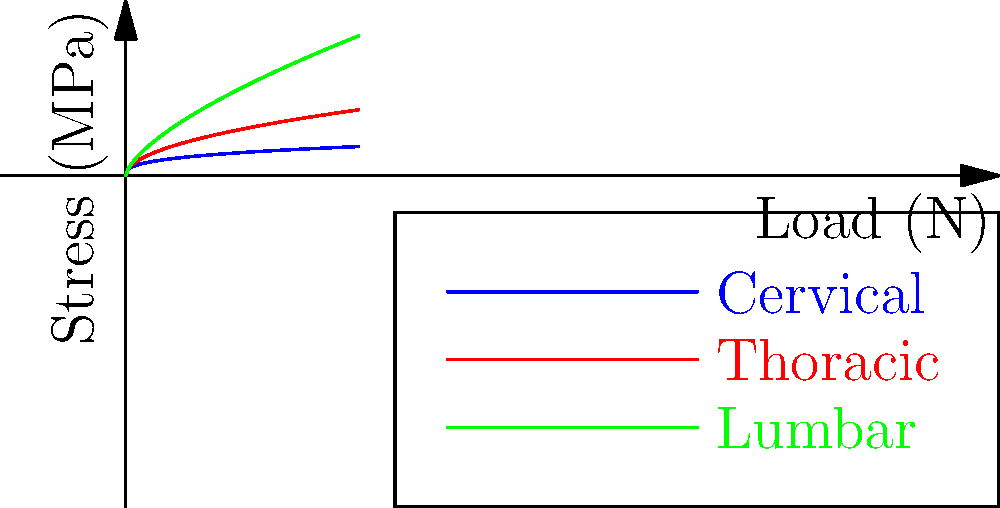In the context of spinal biomechanics, analyze the graph showing stress distribution in different regions of the human spine under various load conditions. Which region of the spine experiences the highest stress under increasing load, and how might this relate to the evolutionary adaptations of human bipedalism? To answer this question, we need to analyze the graph and consider the evolutionary implications:

1. The graph shows stress (MPa) vs. load (N) for three regions of the spine: cervical, thoracic, and lumbar.

2. Examining the curves:
   - Blue curve (Cervical): Lowest stress levels
   - Red curve (Thoracic): Intermediate stress levels
   - Green curve (Lumbar): Highest stress levels

3. The lumbar region (green curve) shows the steepest increase in stress as load increases, indicating it experiences the highest stress under increasing load.

4. Evolutionary context:
   - Human bipedalism evolved relatively recently in our evolutionary history.
   - The lumbar region bears the most weight in an upright posture.
   - Higher stress in the lumbar region aligns with the challenges of adapting to bipedal locomotion.

5. Implications:
   - The lumbar spine's ability to withstand higher stress likely represents an evolutionary adaptation to bipedalism.
   - This adaptation allows for efficient weight transfer through the spine while maintaining an upright posture.
   - The increased stress may also explain why lower back pain is common in humans.

6. Linguistic perspective:
   - Terms like "lumbar," "thoracic," and "cervical" are derived from Latin and Greek, reflecting the historical development of anatomical terminology in English.
   - The use of these terms globally in medical English demonstrates the language's role in scientific communication.
Answer: Lumbar region; adaptation to bipedalism 